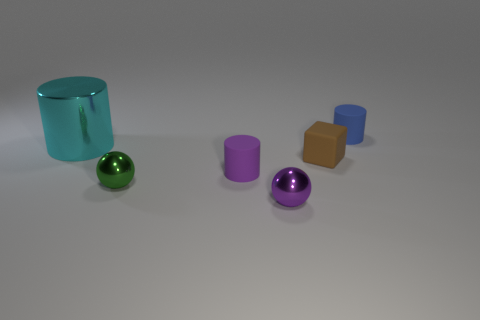Subtract all blue rubber cylinders. How many cylinders are left? 2 Add 1 tiny purple cylinders. How many objects exist? 7 Subtract all green balls. How many balls are left? 1 Subtract all brown balls. How many red blocks are left? 0 Add 5 big metallic things. How many big metallic things exist? 6 Subtract 0 yellow balls. How many objects are left? 6 Subtract all balls. How many objects are left? 4 Subtract 1 blocks. How many blocks are left? 0 Subtract all red cylinders. Subtract all cyan spheres. How many cylinders are left? 3 Subtract all small cyan cylinders. Subtract all matte objects. How many objects are left? 3 